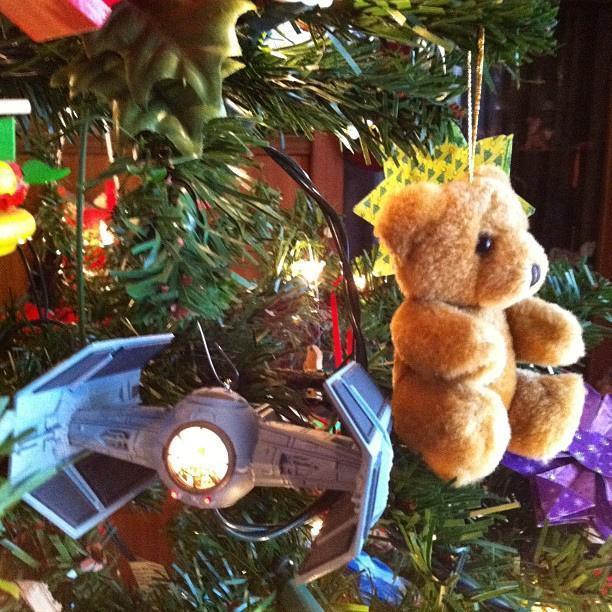How many bears?
Give a very brief answer. 1. How many teddy bears are in the picture?
Give a very brief answer. 1. 